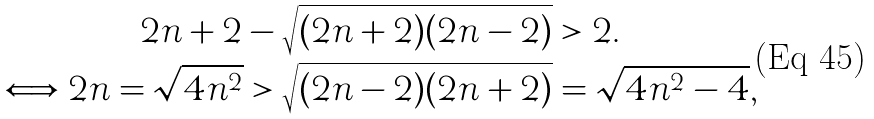Convert formula to latex. <formula><loc_0><loc_0><loc_500><loc_500>2 n + 2 - \sqrt { ( 2 n + 2 ) ( 2 n - 2 ) } & > 2 . \\ \Longleftrightarrow 2 n = \sqrt { 4 n ^ { 2 } } > \sqrt { ( 2 n - 2 ) ( 2 n + 2 ) } & = \sqrt { 4 n ^ { 2 } - 4 } ,</formula> 